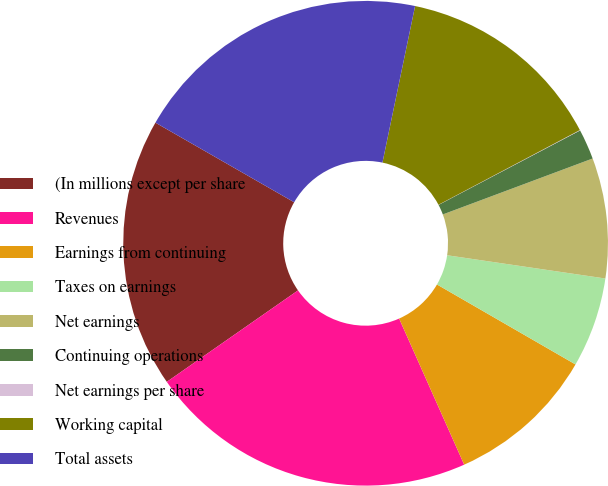Convert chart to OTSL. <chart><loc_0><loc_0><loc_500><loc_500><pie_chart><fcel>(In millions except per share<fcel>Revenues<fcel>Earnings from continuing<fcel>Taxes on earnings<fcel>Net earnings<fcel>Continuing operations<fcel>Net earnings per share<fcel>Working capital<fcel>Total assets<nl><fcel>17.98%<fcel>21.98%<fcel>10.0%<fcel>6.01%<fcel>8.01%<fcel>2.02%<fcel>0.03%<fcel>13.99%<fcel>19.98%<nl></chart> 